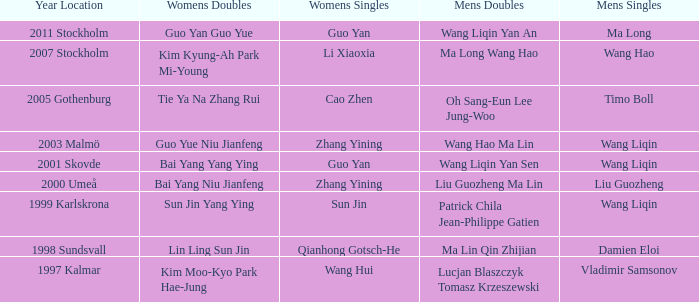What is the place and when was the year when the women's doubles womens were Bai yang Niu Jianfeng? 2000 Umeå. 